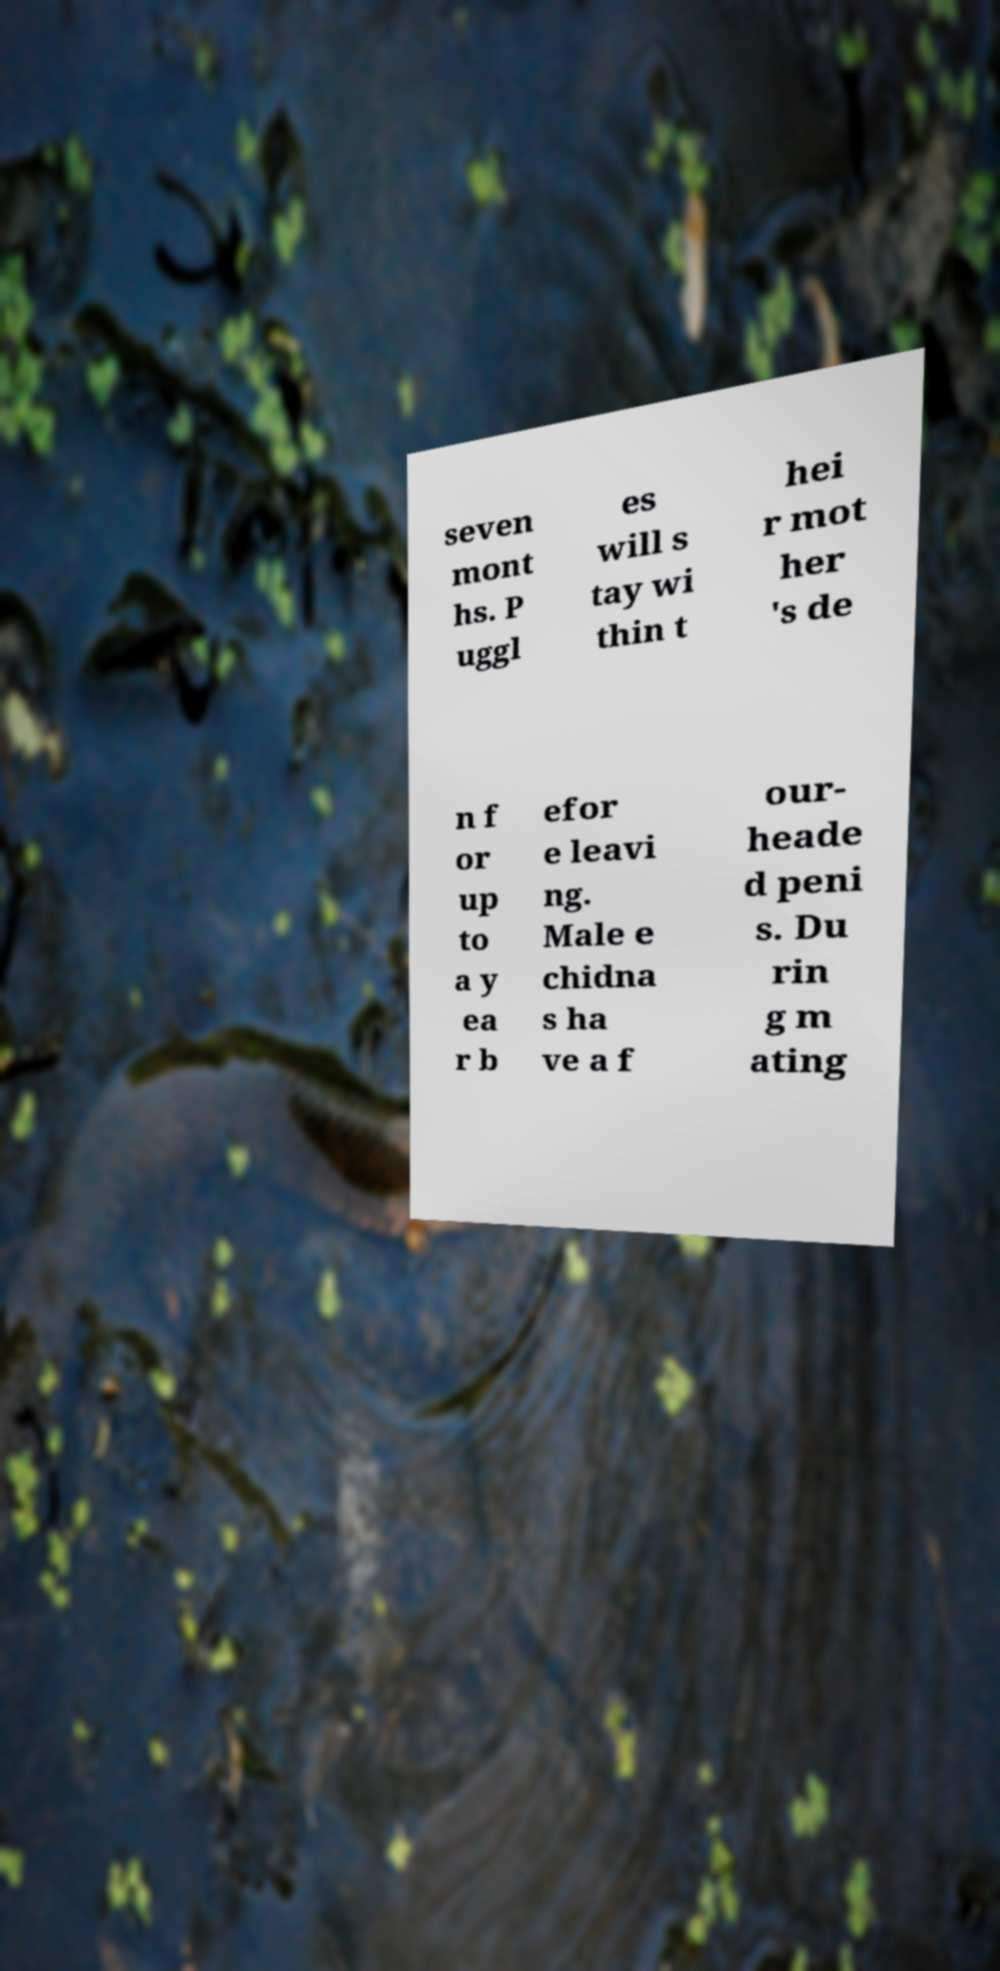Please read and relay the text visible in this image. What does it say? seven mont hs. P uggl es will s tay wi thin t hei r mot her 's de n f or up to a y ea r b efor e leavi ng. Male e chidna s ha ve a f our- heade d peni s. Du rin g m ating 